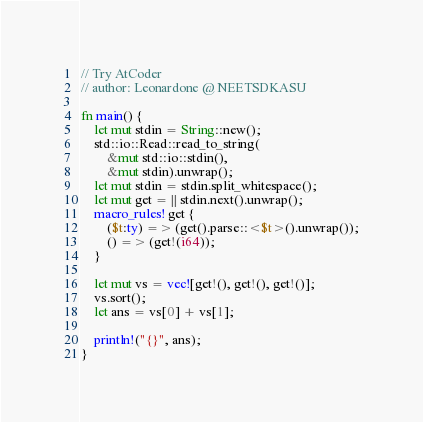Convert code to text. <code><loc_0><loc_0><loc_500><loc_500><_Rust_>// Try AtCoder
// author: Leonardone @ NEETSDKASU

fn main() {
    let mut stdin = String::new();
    std::io::Read::read_to_string(
        &mut std::io::stdin(),
        &mut stdin).unwrap();
    let mut stdin = stdin.split_whitespace();
    let mut get = || stdin.next().unwrap();
    macro_rules! get {
        ($t:ty) => (get().parse::<$t>().unwrap());
        () => (get!(i64));
    }
    
    let mut vs = vec![get!(), get!(), get!()];
    vs.sort();
    let ans = vs[0] + vs[1];
    
    println!("{}", ans);
}</code> 